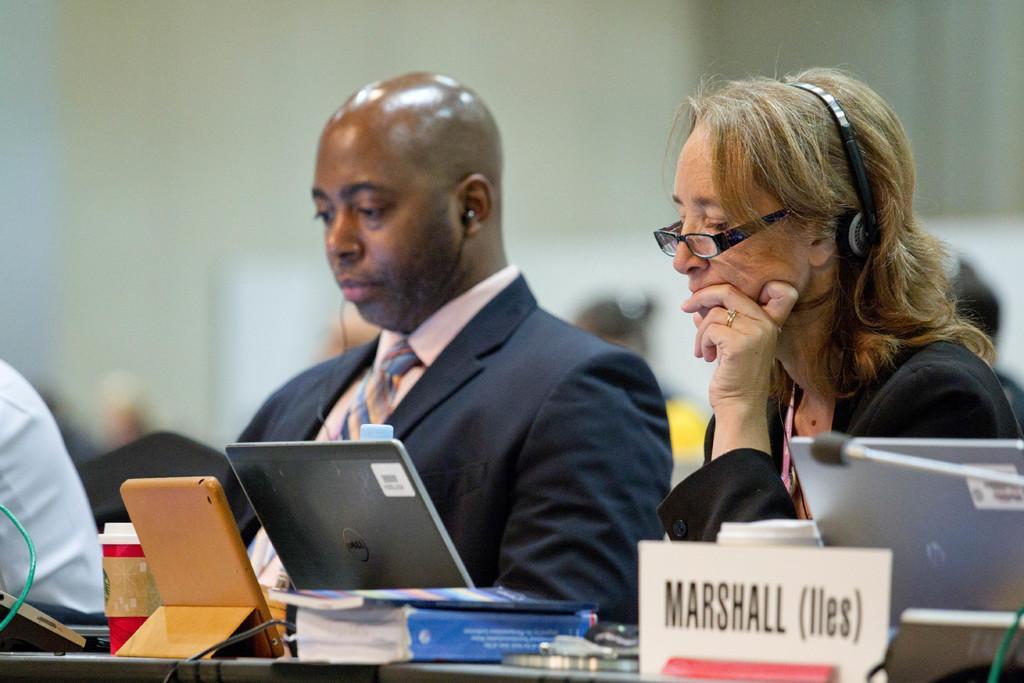Please provide a concise description of this image. In the center of the image we can see two people are sitting on the chairs, in-front of them we can see a table. On the table we can see the laptop's, mic with stand, board, books, bottle, tab and some other objects. In the background of the image we can see some people are sitting. At the top, the image is blurred. 